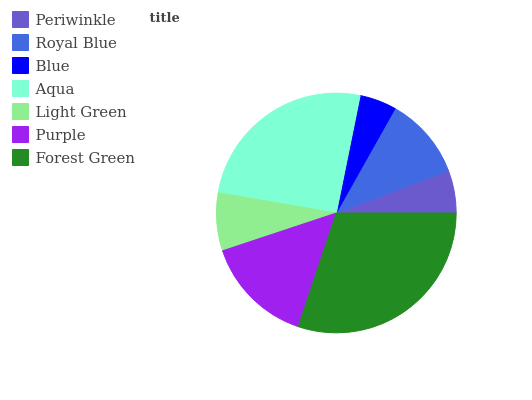Is Blue the minimum?
Answer yes or no. Yes. Is Forest Green the maximum?
Answer yes or no. Yes. Is Royal Blue the minimum?
Answer yes or no. No. Is Royal Blue the maximum?
Answer yes or no. No. Is Royal Blue greater than Periwinkle?
Answer yes or no. Yes. Is Periwinkle less than Royal Blue?
Answer yes or no. Yes. Is Periwinkle greater than Royal Blue?
Answer yes or no. No. Is Royal Blue less than Periwinkle?
Answer yes or no. No. Is Royal Blue the high median?
Answer yes or no. Yes. Is Royal Blue the low median?
Answer yes or no. Yes. Is Purple the high median?
Answer yes or no. No. Is Forest Green the low median?
Answer yes or no. No. 